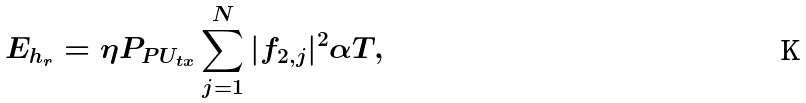<formula> <loc_0><loc_0><loc_500><loc_500>E _ { h _ { r } } = \eta P _ { P U _ { t x } } \sum _ { j = 1 } ^ { N } | f _ { 2 , j } | ^ { 2 } \alpha T ,</formula> 